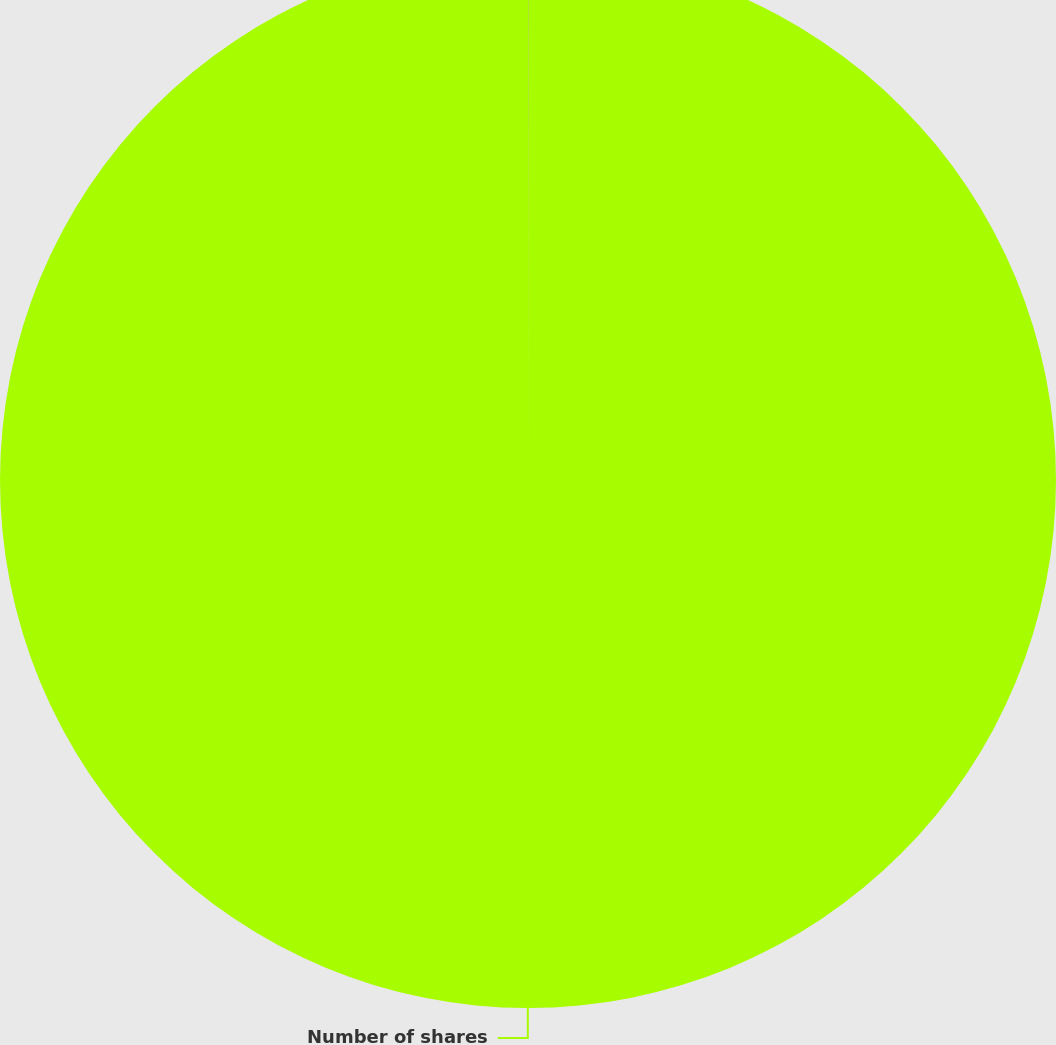<chart> <loc_0><loc_0><loc_500><loc_500><pie_chart><fcel>Expense ( millions)<fcel>Number of shares<nl><fcel>0.01%<fcel>99.99%<nl></chart> 